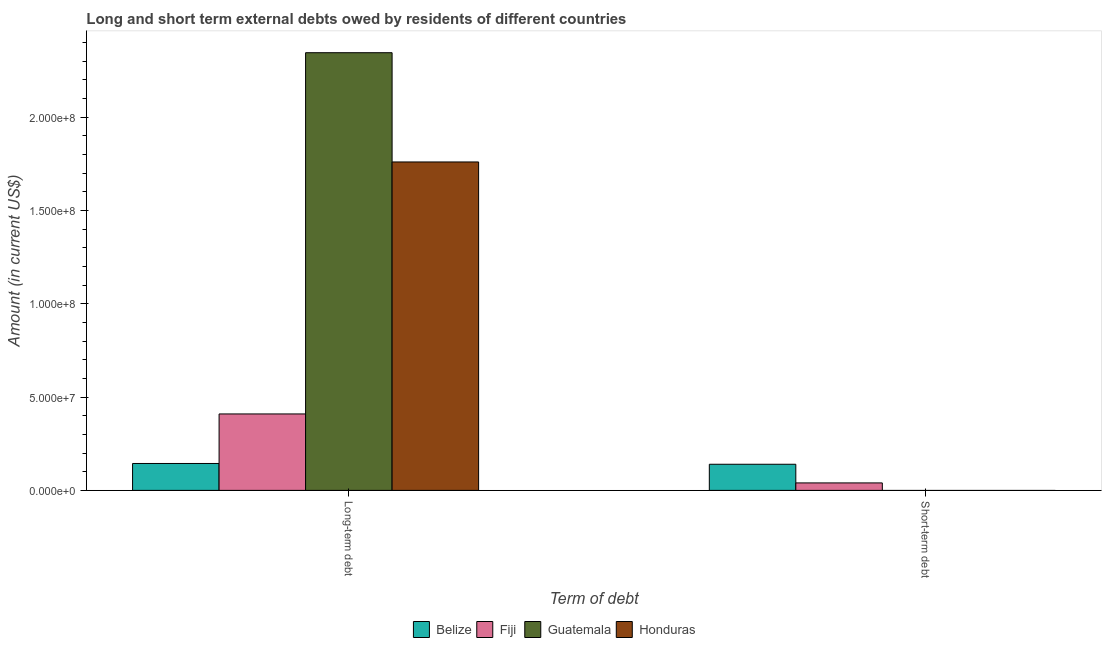How many different coloured bars are there?
Ensure brevity in your answer.  4. Are the number of bars per tick equal to the number of legend labels?
Provide a succinct answer. No. What is the label of the 1st group of bars from the left?
Ensure brevity in your answer.  Long-term debt. What is the short-term debts owed by residents in Guatemala?
Provide a succinct answer. 0. Across all countries, what is the maximum short-term debts owed by residents?
Offer a very short reply. 1.40e+07. Across all countries, what is the minimum long-term debts owed by residents?
Your answer should be very brief. 1.44e+07. In which country was the short-term debts owed by residents maximum?
Make the answer very short. Belize. What is the total short-term debts owed by residents in the graph?
Your response must be concise. 1.80e+07. What is the difference between the long-term debts owed by residents in Fiji and that in Belize?
Keep it short and to the point. 2.65e+07. What is the difference between the short-term debts owed by residents in Honduras and the long-term debts owed by residents in Fiji?
Provide a short and direct response. -4.10e+07. What is the average long-term debts owed by residents per country?
Ensure brevity in your answer.  1.17e+08. What is the difference between the short-term debts owed by residents and long-term debts owed by residents in Fiji?
Offer a terse response. -3.70e+07. In how many countries, is the short-term debts owed by residents greater than 220000000 US$?
Provide a succinct answer. 0. What is the ratio of the long-term debts owed by residents in Guatemala to that in Honduras?
Keep it short and to the point. 1.33. Is the long-term debts owed by residents in Belize less than that in Fiji?
Provide a short and direct response. Yes. What is the difference between two consecutive major ticks on the Y-axis?
Ensure brevity in your answer.  5.00e+07. What is the title of the graph?
Give a very brief answer. Long and short term external debts owed by residents of different countries. Does "Canada" appear as one of the legend labels in the graph?
Your response must be concise. No. What is the label or title of the X-axis?
Ensure brevity in your answer.  Term of debt. What is the Amount (in current US$) of Belize in Long-term debt?
Your answer should be compact. 1.44e+07. What is the Amount (in current US$) of Fiji in Long-term debt?
Provide a short and direct response. 4.10e+07. What is the Amount (in current US$) of Guatemala in Long-term debt?
Your answer should be very brief. 2.35e+08. What is the Amount (in current US$) in Honduras in Long-term debt?
Your answer should be very brief. 1.76e+08. What is the Amount (in current US$) of Belize in Short-term debt?
Your answer should be compact. 1.40e+07. What is the Amount (in current US$) of Fiji in Short-term debt?
Give a very brief answer. 4.00e+06. What is the Amount (in current US$) of Guatemala in Short-term debt?
Your response must be concise. 0. What is the Amount (in current US$) of Honduras in Short-term debt?
Your answer should be compact. 0. Across all Term of debt, what is the maximum Amount (in current US$) of Belize?
Make the answer very short. 1.44e+07. Across all Term of debt, what is the maximum Amount (in current US$) in Fiji?
Ensure brevity in your answer.  4.10e+07. Across all Term of debt, what is the maximum Amount (in current US$) in Guatemala?
Your answer should be compact. 2.35e+08. Across all Term of debt, what is the maximum Amount (in current US$) of Honduras?
Your response must be concise. 1.76e+08. Across all Term of debt, what is the minimum Amount (in current US$) of Belize?
Your response must be concise. 1.40e+07. Across all Term of debt, what is the minimum Amount (in current US$) of Honduras?
Provide a short and direct response. 0. What is the total Amount (in current US$) of Belize in the graph?
Your answer should be very brief. 2.84e+07. What is the total Amount (in current US$) of Fiji in the graph?
Provide a short and direct response. 4.50e+07. What is the total Amount (in current US$) of Guatemala in the graph?
Your response must be concise. 2.35e+08. What is the total Amount (in current US$) in Honduras in the graph?
Your answer should be compact. 1.76e+08. What is the difference between the Amount (in current US$) of Belize in Long-term debt and that in Short-term debt?
Provide a short and direct response. 4.17e+05. What is the difference between the Amount (in current US$) in Fiji in Long-term debt and that in Short-term debt?
Offer a very short reply. 3.70e+07. What is the difference between the Amount (in current US$) in Belize in Long-term debt and the Amount (in current US$) in Fiji in Short-term debt?
Offer a very short reply. 1.04e+07. What is the average Amount (in current US$) of Belize per Term of debt?
Offer a very short reply. 1.42e+07. What is the average Amount (in current US$) of Fiji per Term of debt?
Give a very brief answer. 2.25e+07. What is the average Amount (in current US$) of Guatemala per Term of debt?
Ensure brevity in your answer.  1.17e+08. What is the average Amount (in current US$) of Honduras per Term of debt?
Your response must be concise. 8.80e+07. What is the difference between the Amount (in current US$) in Belize and Amount (in current US$) in Fiji in Long-term debt?
Provide a short and direct response. -2.65e+07. What is the difference between the Amount (in current US$) of Belize and Amount (in current US$) of Guatemala in Long-term debt?
Your answer should be very brief. -2.20e+08. What is the difference between the Amount (in current US$) of Belize and Amount (in current US$) of Honduras in Long-term debt?
Provide a succinct answer. -1.62e+08. What is the difference between the Amount (in current US$) of Fiji and Amount (in current US$) of Guatemala in Long-term debt?
Offer a very short reply. -1.94e+08. What is the difference between the Amount (in current US$) of Fiji and Amount (in current US$) of Honduras in Long-term debt?
Offer a very short reply. -1.35e+08. What is the difference between the Amount (in current US$) of Guatemala and Amount (in current US$) of Honduras in Long-term debt?
Make the answer very short. 5.86e+07. What is the difference between the Amount (in current US$) in Belize and Amount (in current US$) in Fiji in Short-term debt?
Keep it short and to the point. 1.00e+07. What is the ratio of the Amount (in current US$) of Belize in Long-term debt to that in Short-term debt?
Provide a short and direct response. 1.03. What is the ratio of the Amount (in current US$) in Fiji in Long-term debt to that in Short-term debt?
Keep it short and to the point. 10.24. What is the difference between the highest and the second highest Amount (in current US$) in Belize?
Offer a terse response. 4.17e+05. What is the difference between the highest and the second highest Amount (in current US$) in Fiji?
Offer a terse response. 3.70e+07. What is the difference between the highest and the lowest Amount (in current US$) of Belize?
Provide a short and direct response. 4.17e+05. What is the difference between the highest and the lowest Amount (in current US$) of Fiji?
Provide a succinct answer. 3.70e+07. What is the difference between the highest and the lowest Amount (in current US$) in Guatemala?
Your answer should be very brief. 2.35e+08. What is the difference between the highest and the lowest Amount (in current US$) in Honduras?
Offer a very short reply. 1.76e+08. 